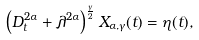Convert formula to latex. <formula><loc_0><loc_0><loc_500><loc_500>\left ( D _ { t } ^ { 2 \alpha } + \lambda ^ { 2 \alpha } \right ) ^ { \frac { \gamma } { 2 } } X _ { \alpha , \gamma } ( t ) = \eta ( t ) ,</formula> 